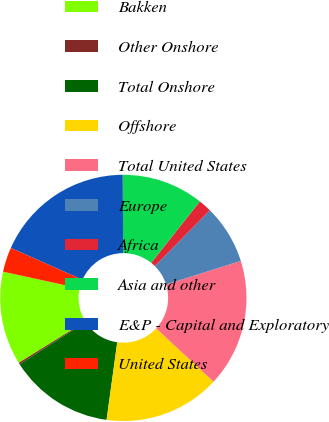Convert chart. <chart><loc_0><loc_0><loc_500><loc_500><pie_chart><fcel>Bakken<fcel>Other Onshore<fcel>Total Onshore<fcel>Offshore<fcel>Total United States<fcel>Europe<fcel>Africa<fcel>Asia and other<fcel>E&P - Capital and Exploratory<fcel>United States<nl><fcel>12.26%<fcel>0.22%<fcel>13.76%<fcel>15.26%<fcel>16.77%<fcel>7.74%<fcel>1.73%<fcel>10.75%<fcel>18.27%<fcel>3.23%<nl></chart> 